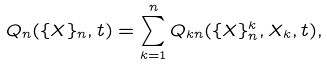<formula> <loc_0><loc_0><loc_500><loc_500>Q _ { n } ( \{ X \} _ { n } , t ) = \sum _ { k = 1 } ^ { n } Q _ { k n } ( \{ X \} _ { n } ^ { k } , X _ { k } , t ) ,</formula> 